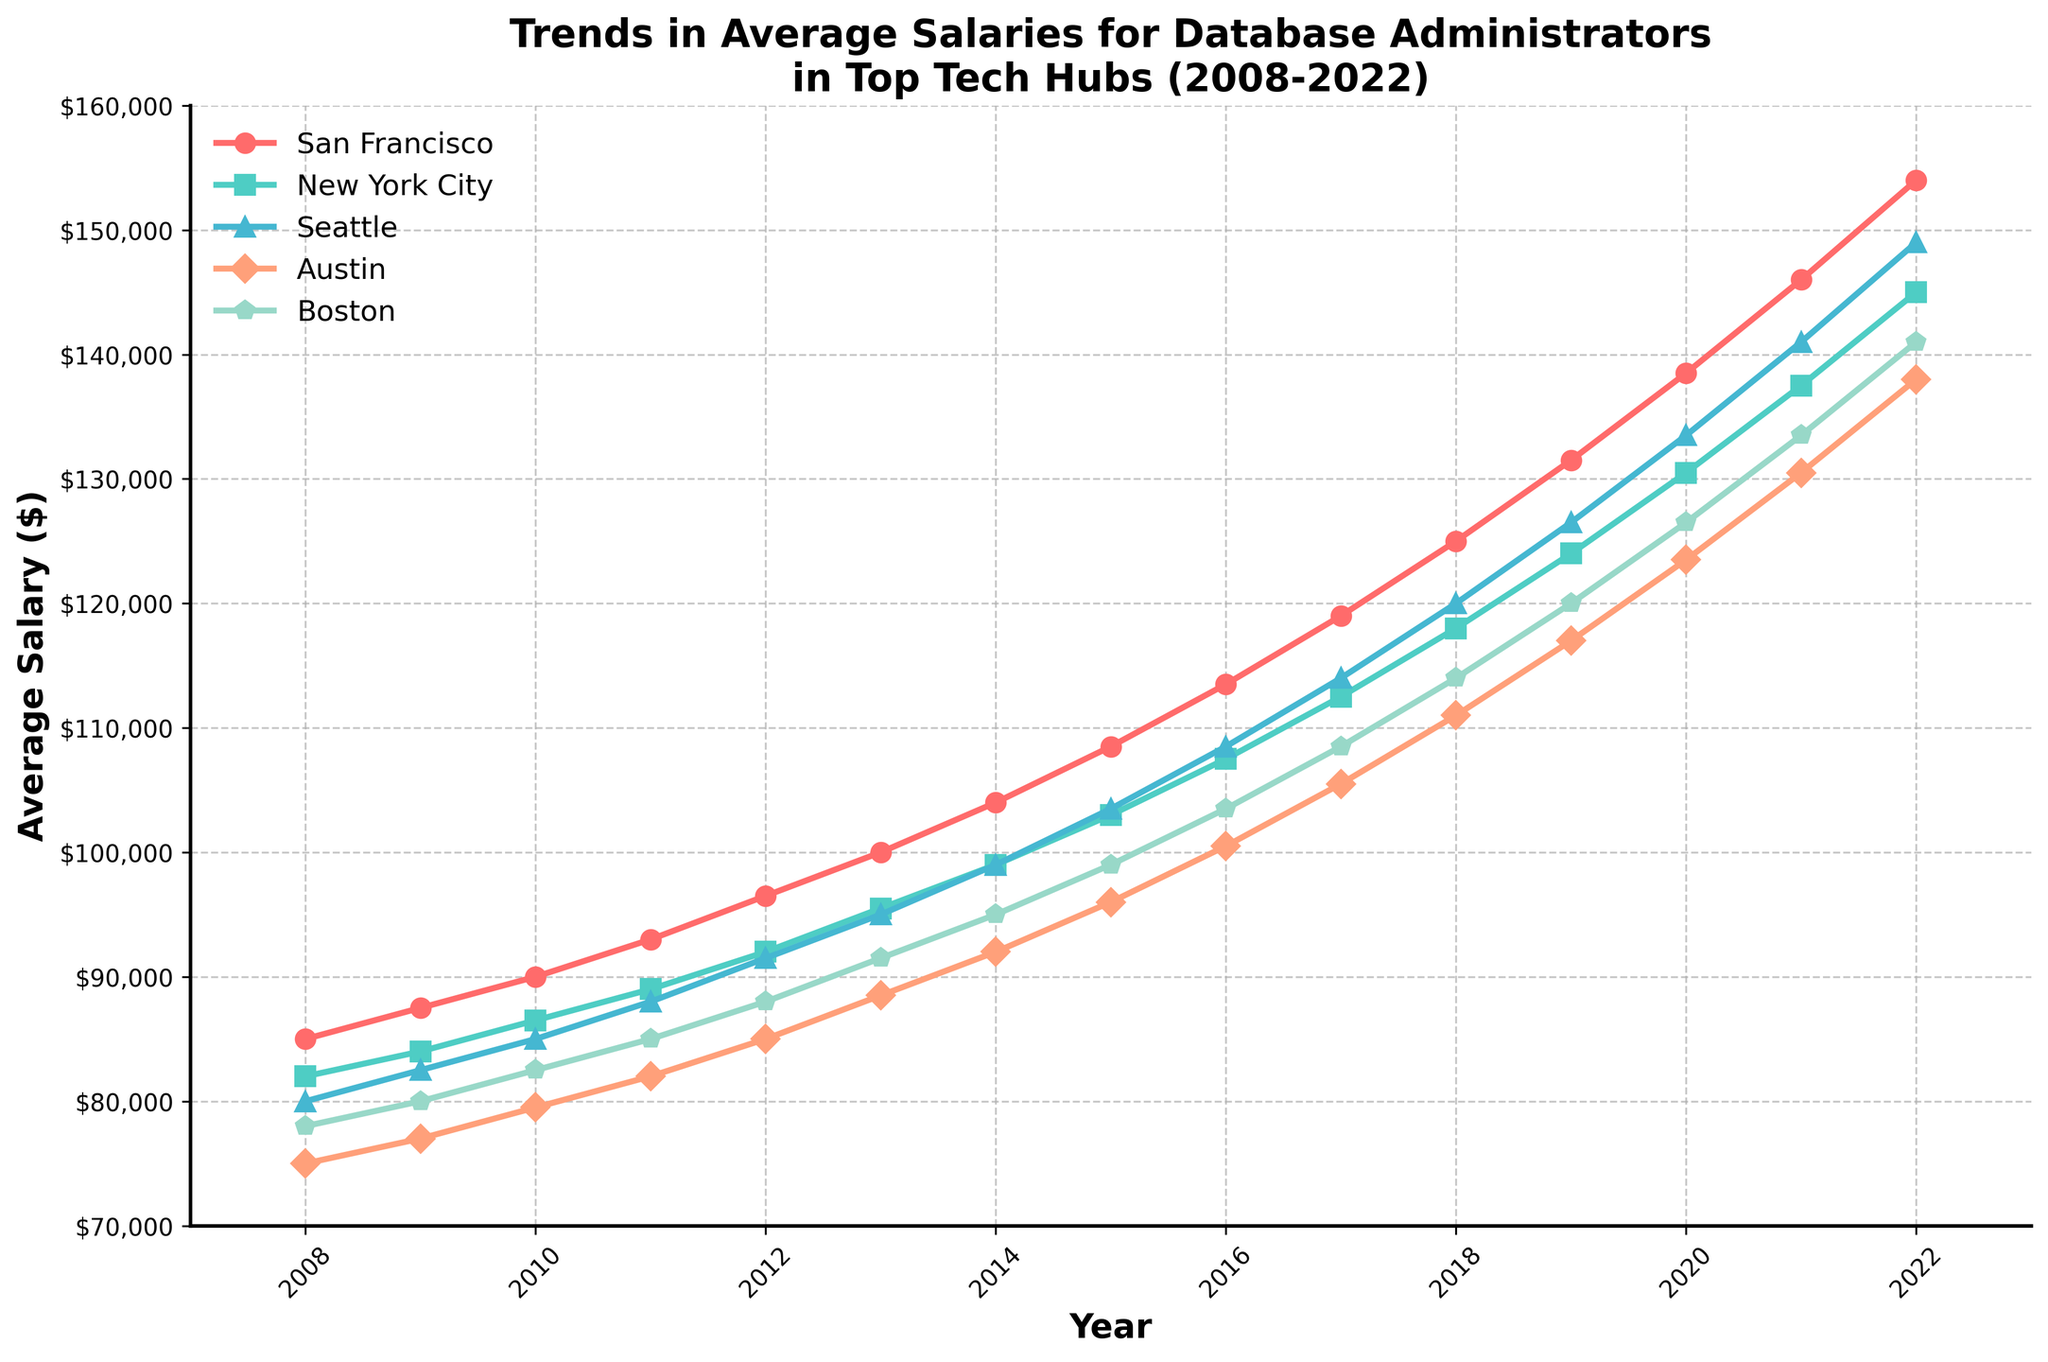What is the overall trend in average salaries for San Francisco from 2008 to 2022? To determine the overall trend, observe the line representing San Francisco from the left (2008) to the right (2022). The line generally increases from $85,000 in 2008 to $154,000 in 2022. Thus, there is a consistent upward trend.
Answer: Upward Which city had the highest average salary for database administrators in 2022? Look at the end point for each city's line in 2022 and compare their values. San Francisco reaches the highest point at $154,000.
Answer: San Francisco How much did the average salary in Seattle increase from 2008 to 2022? Find the value for Seattle in 2008 ($80,000) and in 2022 ($149,000). Calculate the difference: $149,000 - $80,000 = $69,000.
Answer: $69,000 Which city had the smallest increase in average salary between 2008 and 2022? Calculate the difference between 2022 and 2008 salaries for each city: San Francisco ($154,000 - $85,000 = $69,000), New York City ($145,000 - $82,000 = $63,000), Seattle ($149,000 - $80,000 = $69,000), Austin ($138,000 - $75,000 = $63,000), Boston ($141,000 - $78,000 = $63,000). New York City, Austin, and Boston all had the smallest increase of $63,000.
Answer: New York City, Austin, Boston What year did New York City first surpass an average salary of $100,000? Trace the line for New York City and find the year where it first reaches or exceeds $100,000. The year is 2014.
Answer: 2014 Rank the cities by their average salary in 2019 from highest to lowest. Observe the data points for 2019: San Francisco ($131,500), New York City ($124,000), Seattle ($126,500), Austin ($117,000), Boston ($120,000). Rank them: San Francisco ($131,500), Seattle ($126,500), New York City ($124,000), Boston ($120,000), Austin ($117,000).
Answer: San Francisco, Seattle, New York City, Boston, Austin In which city did database administrators see their salaries increase the fastest between 2016 and 2018? Examine the difference in salary values from 2016 to 2018 for all cities: San Francisco ($125,000 - $113,500 = $11,500), New York City ($118,000 - $107,500 = $10,500), Seattle ($120,000 - $108,500 = $11,500), Austin ($111,000 - $100,500 = $10,500), Boston ($114,000 - $103,500 = $10,500). Both San Francisco and Seattle had the fastest increase of $11,500.
Answer: San Francisco, Seattle Which city showed the most consistent growth in average salary over the 15 years? Consistent growth implies a smooth, steadily increasing line without major fluctuations. Observing the lines, San Francisco appears to show the most consistent and steady growth.
Answer: San Francisco Compare the difference in starting and ending average salaries for Austin and Boston. Which city had a larger increase? Austin's increase: $138,000 - $75,000 = $63,000. Boston's increase: $141,000 - $78,000 = $63,000. Both cities had the same increase.
Answer: Both cities had the same increase 